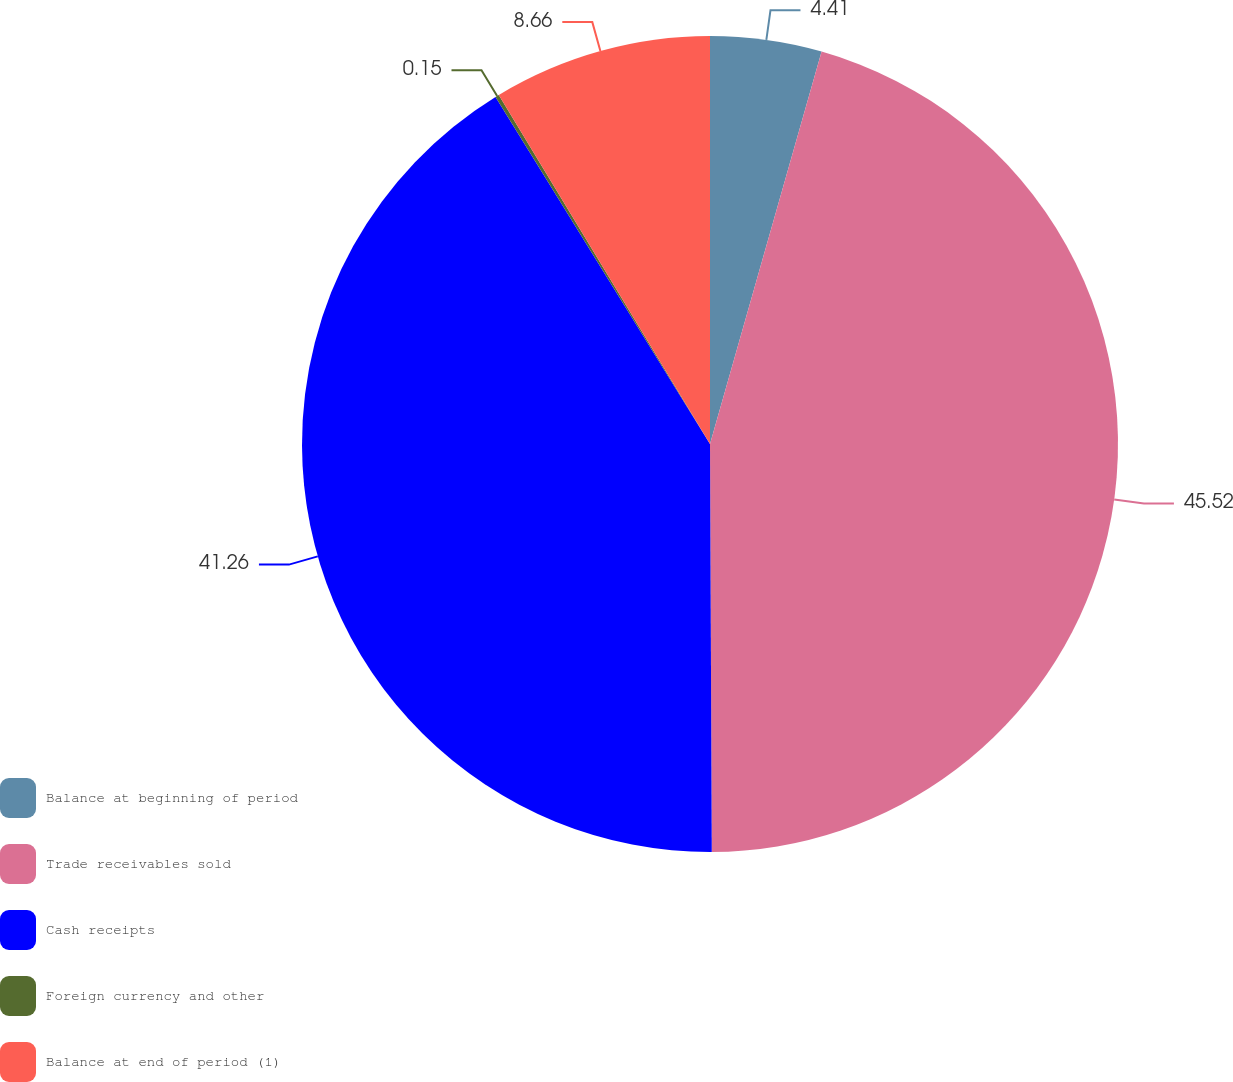Convert chart. <chart><loc_0><loc_0><loc_500><loc_500><pie_chart><fcel>Balance at beginning of period<fcel>Trade receivables sold<fcel>Cash receipts<fcel>Foreign currency and other<fcel>Balance at end of period (1)<nl><fcel>4.41%<fcel>45.52%<fcel>41.26%<fcel>0.15%<fcel>8.66%<nl></chart> 